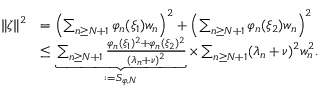<formula> <loc_0><loc_0><loc_500><loc_500>\begin{array} { r l } { \| \zeta \| ^ { 2 } } & { = \left ( \sum _ { n \geq N + 1 } \varphi _ { n } ( \xi _ { 1 } ) w _ { n } \right ) ^ { 2 } + \left ( \sum _ { n \geq N + 1 } \varphi _ { n } ( \xi _ { 2 } ) w _ { n } \right ) ^ { 2 } } \\ & { \leq \underbrace { \sum _ { n \geq N + 1 } \frac { \varphi _ { n } ( \xi _ { 1 } ) ^ { 2 } + \varphi _ { n } ( \xi _ { 2 } ) ^ { 2 } } { ( \lambda _ { n } + \nu ) ^ { 2 } } } _ { \colon = S _ { \varphi , N } } \times \sum _ { n \geq N + 1 } ( \lambda _ { n } + \nu ) ^ { 2 } w _ { n } ^ { 2 } . } \end{array}</formula> 